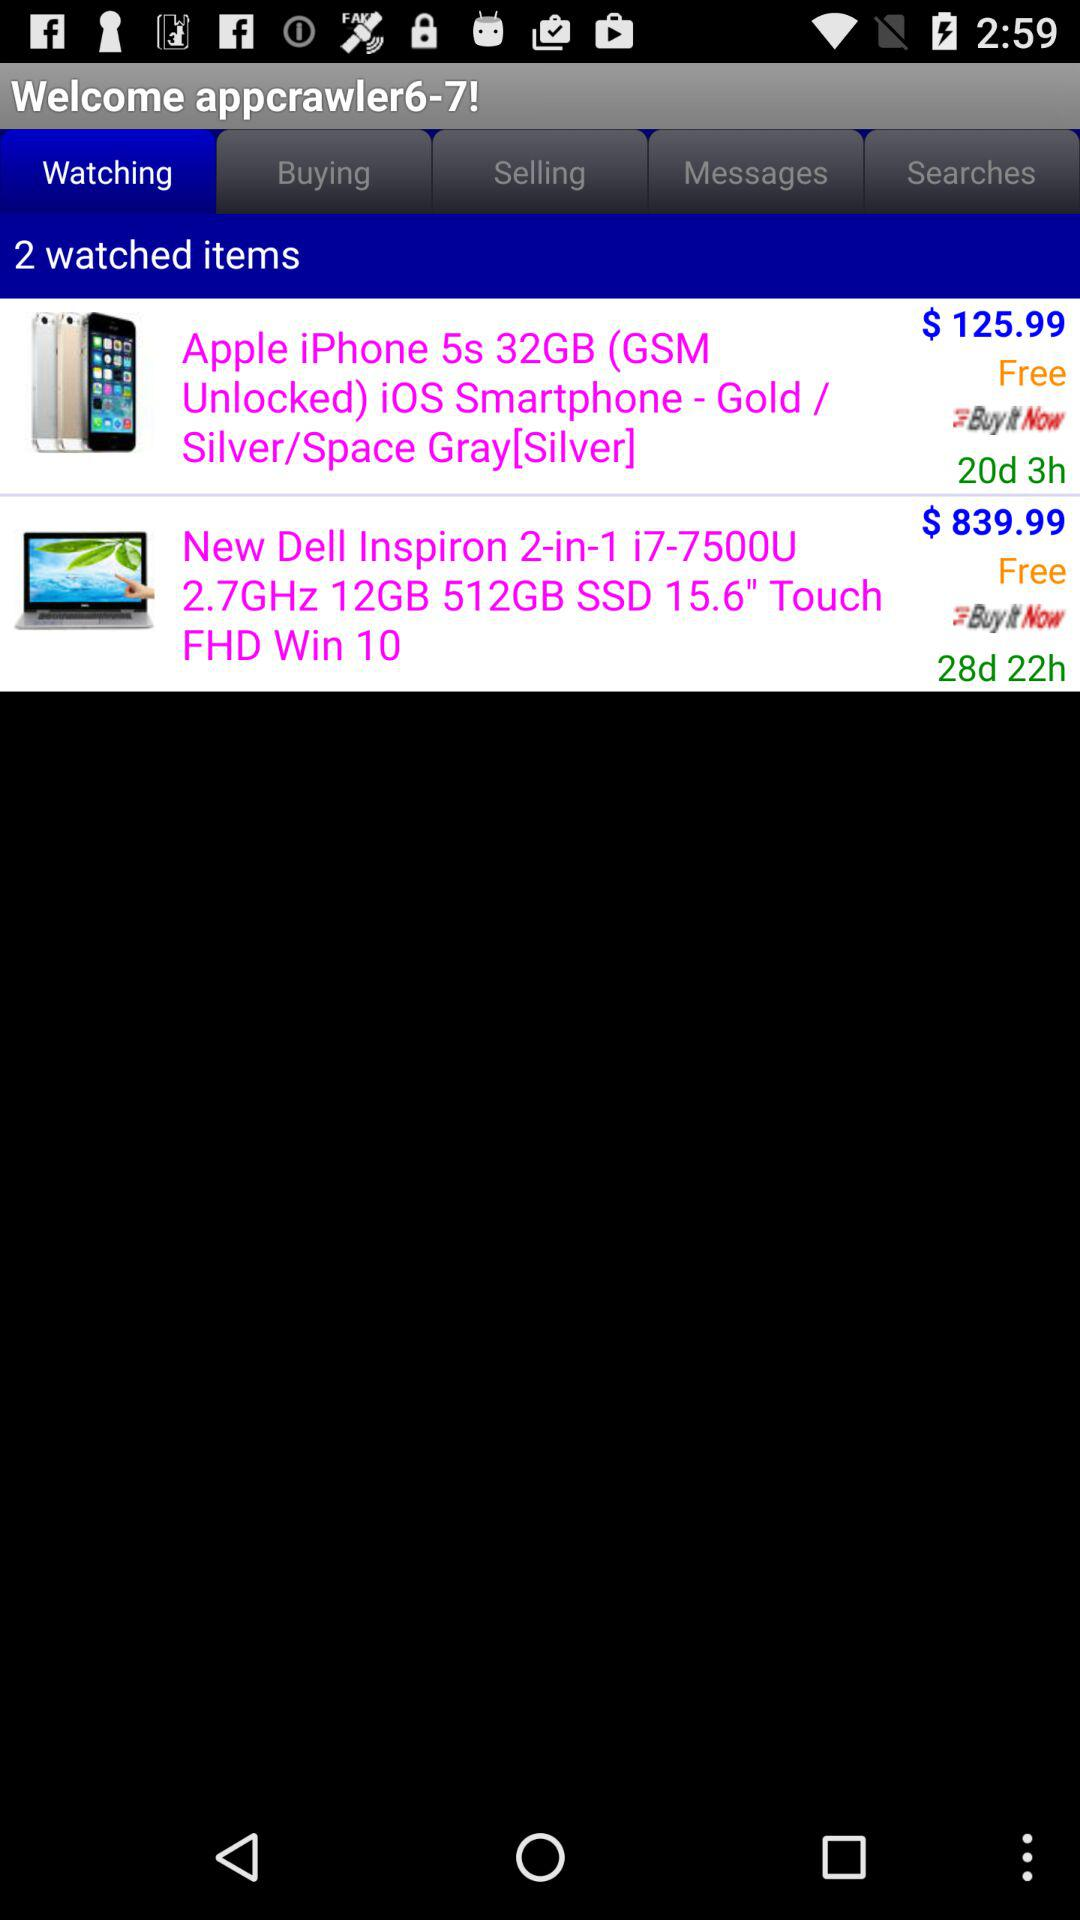What is the delivery time of a new Dell Inspiron laptop?
When the provided information is insufficient, respond with <no answer>. <no answer> 